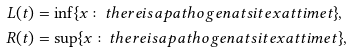<formula> <loc_0><loc_0><loc_500><loc_500>L ( t ) & = \inf \{ x \colon t h e r e i s a p a t h o g e n a t s i t e x a t t i m e t \} , \\ R ( t ) & = \sup \{ x \colon t h e r e i s a p a t h o g e n a t s i t e x a t t i m e t \} ,</formula> 